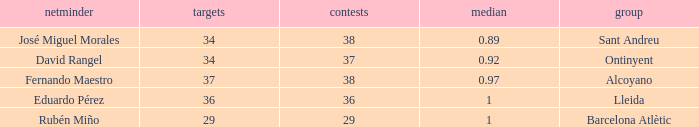What is the highest Average, when Goals is "34", and when Matches is less than 37? None. 